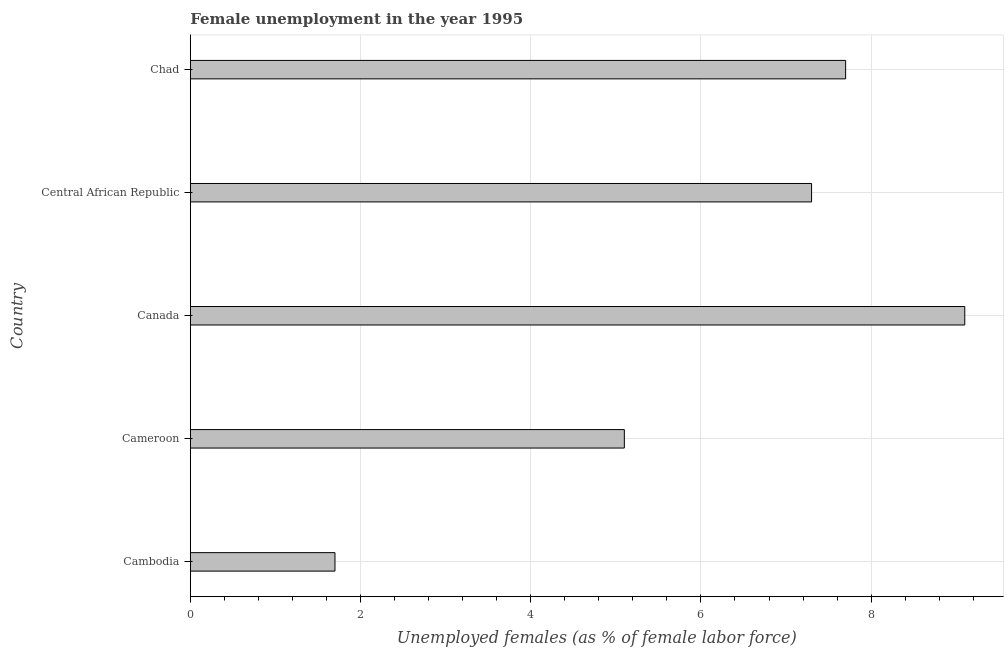Does the graph contain any zero values?
Offer a very short reply. No. What is the title of the graph?
Offer a terse response. Female unemployment in the year 1995. What is the label or title of the X-axis?
Offer a very short reply. Unemployed females (as % of female labor force). What is the unemployed females population in Canada?
Ensure brevity in your answer.  9.1. Across all countries, what is the maximum unemployed females population?
Give a very brief answer. 9.1. Across all countries, what is the minimum unemployed females population?
Offer a terse response. 1.7. In which country was the unemployed females population minimum?
Your answer should be compact. Cambodia. What is the sum of the unemployed females population?
Make the answer very short. 30.9. What is the average unemployed females population per country?
Give a very brief answer. 6.18. What is the median unemployed females population?
Provide a succinct answer. 7.3. What is the ratio of the unemployed females population in Canada to that in Chad?
Provide a succinct answer. 1.18. Is the unemployed females population in Cambodia less than that in Chad?
Give a very brief answer. Yes. Is the sum of the unemployed females population in Canada and Central African Republic greater than the maximum unemployed females population across all countries?
Your response must be concise. Yes. Are all the bars in the graph horizontal?
Make the answer very short. Yes. Are the values on the major ticks of X-axis written in scientific E-notation?
Offer a terse response. No. What is the Unemployed females (as % of female labor force) of Cambodia?
Offer a very short reply. 1.7. What is the Unemployed females (as % of female labor force) of Cameroon?
Make the answer very short. 5.1. What is the Unemployed females (as % of female labor force) in Canada?
Keep it short and to the point. 9.1. What is the Unemployed females (as % of female labor force) of Central African Republic?
Your response must be concise. 7.3. What is the Unemployed females (as % of female labor force) in Chad?
Offer a very short reply. 7.7. What is the difference between the Unemployed females (as % of female labor force) in Cambodia and Central African Republic?
Provide a short and direct response. -5.6. What is the difference between the Unemployed females (as % of female labor force) in Cambodia and Chad?
Ensure brevity in your answer.  -6. What is the difference between the Unemployed females (as % of female labor force) in Cameroon and Canada?
Offer a very short reply. -4. What is the difference between the Unemployed females (as % of female labor force) in Cameroon and Central African Republic?
Provide a succinct answer. -2.2. What is the difference between the Unemployed females (as % of female labor force) in Canada and Chad?
Provide a short and direct response. 1.4. What is the difference between the Unemployed females (as % of female labor force) in Central African Republic and Chad?
Your answer should be very brief. -0.4. What is the ratio of the Unemployed females (as % of female labor force) in Cambodia to that in Cameroon?
Ensure brevity in your answer.  0.33. What is the ratio of the Unemployed females (as % of female labor force) in Cambodia to that in Canada?
Make the answer very short. 0.19. What is the ratio of the Unemployed females (as % of female labor force) in Cambodia to that in Central African Republic?
Offer a very short reply. 0.23. What is the ratio of the Unemployed females (as % of female labor force) in Cambodia to that in Chad?
Offer a terse response. 0.22. What is the ratio of the Unemployed females (as % of female labor force) in Cameroon to that in Canada?
Offer a terse response. 0.56. What is the ratio of the Unemployed females (as % of female labor force) in Cameroon to that in Central African Republic?
Give a very brief answer. 0.7. What is the ratio of the Unemployed females (as % of female labor force) in Cameroon to that in Chad?
Your answer should be very brief. 0.66. What is the ratio of the Unemployed females (as % of female labor force) in Canada to that in Central African Republic?
Make the answer very short. 1.25. What is the ratio of the Unemployed females (as % of female labor force) in Canada to that in Chad?
Your answer should be compact. 1.18. What is the ratio of the Unemployed females (as % of female labor force) in Central African Republic to that in Chad?
Make the answer very short. 0.95. 